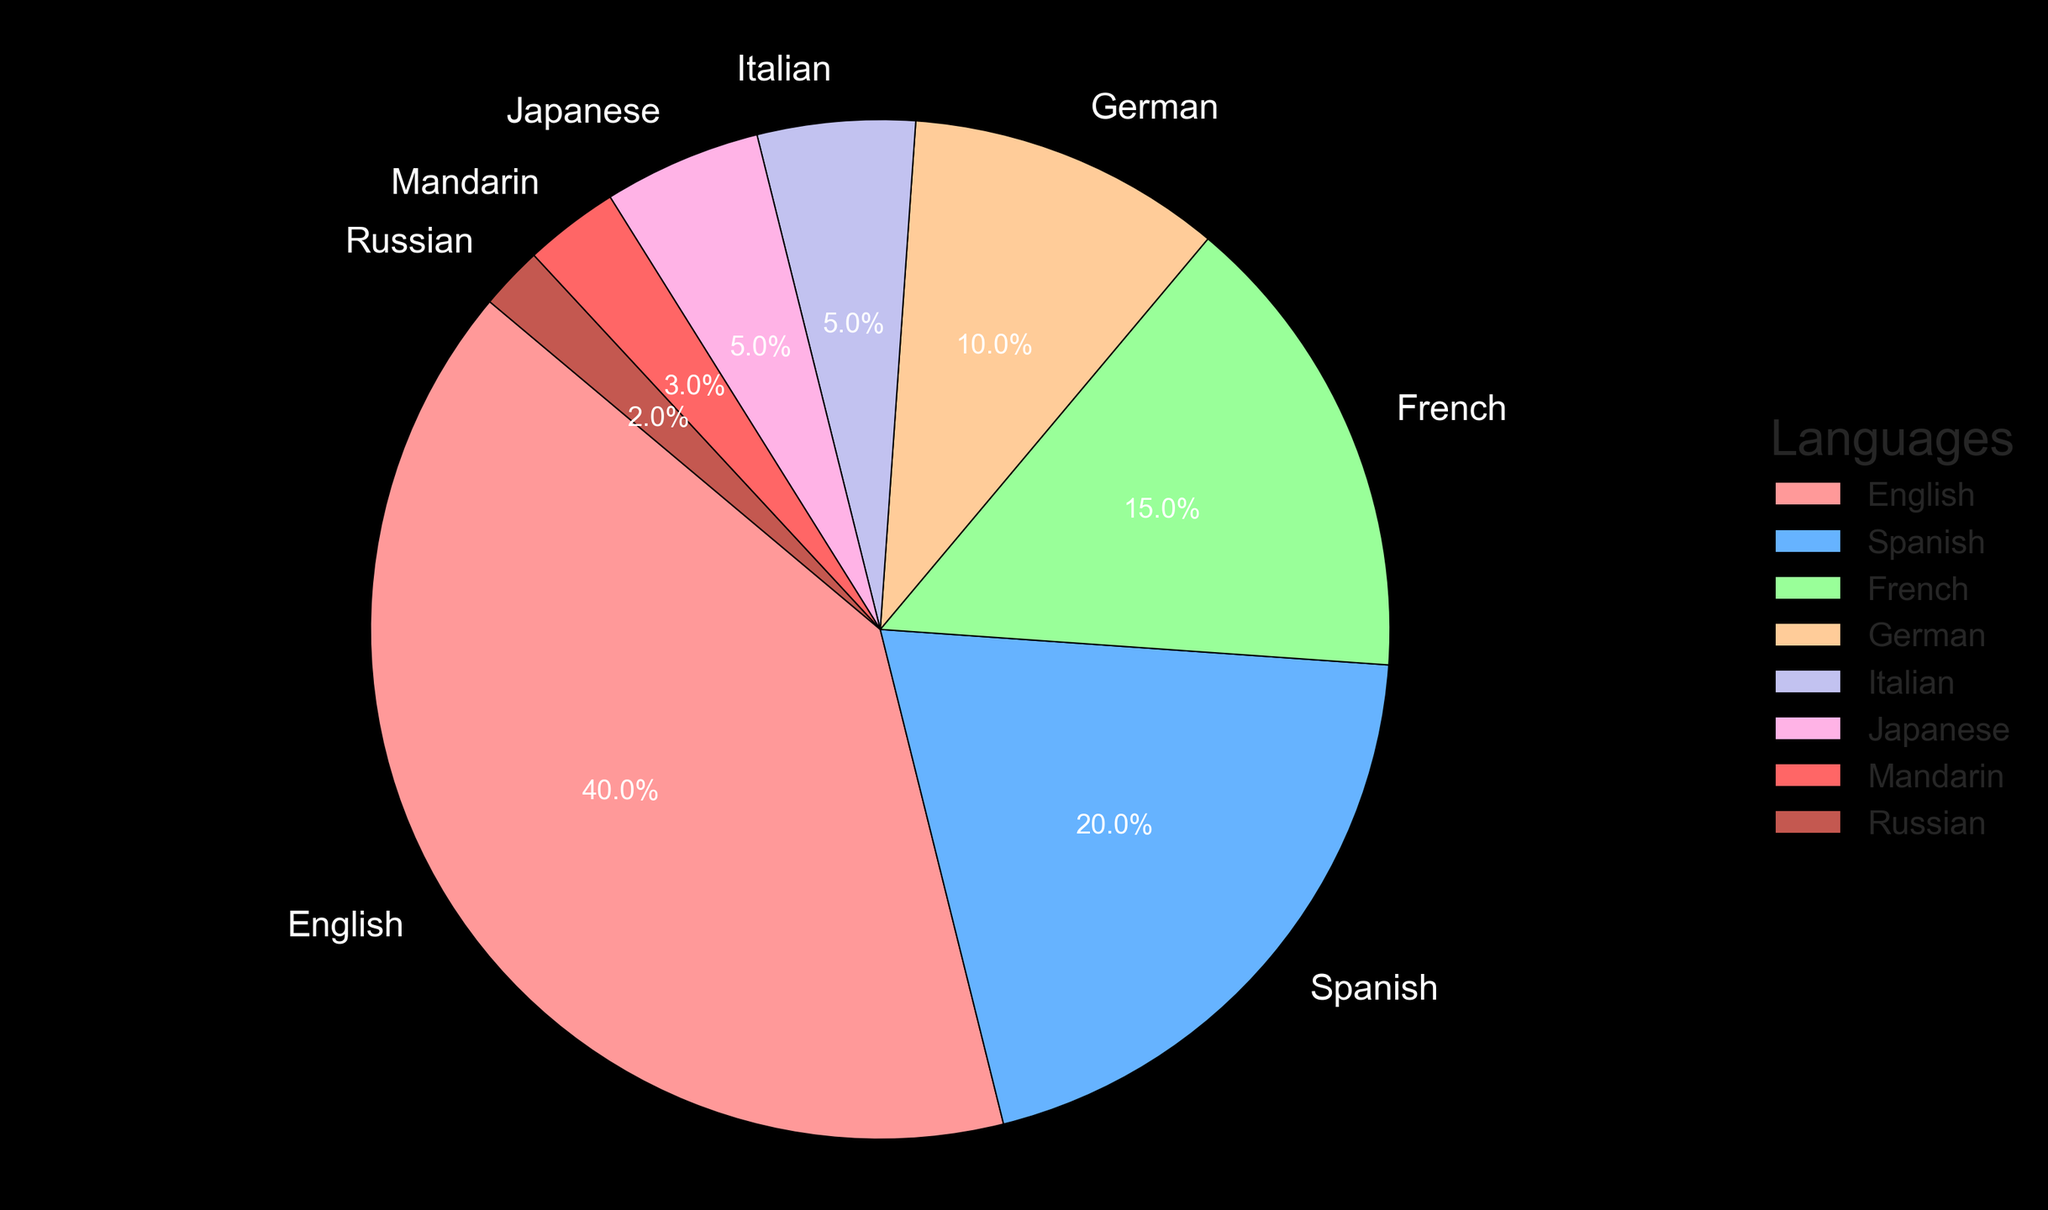What percentage of subtitles are available in Spanish? The pie chart shows the percentage of subtitles for each language, and Spanish makes up 20% of the total.
Answer: 20% What is the combined percentage of subtitles available in French and German? From the pie chart, French subtitles are 15% and German subtitles are 10%. Adding these together gives 15% + 10% = 25%.
Answer: 25% Which language has the third most available subtitles? According to the pie chart, the languages and their percentages in descending order are English (40%), Spanish (20%), and French (15%). Therefore, French has the third most available subtitles.
Answer: French Are there more subtitles available in Japanese or Russian? From the pie chart, Japanese subtitles are 5% of the total, while Russian subtitles are 2%. Therefore, there are more subtitles available in Japanese than in Russian.
Answer: Japanese What percentage of subtitles are available in languages other than English? English subtitles account for 40%, so the remaining percentage is 100% - 40% = 60%.
Answer: 60% Which two languages together make up a smaller percentage than English alone? From the pie chart, English is 40%. The next highest percentages are Spanish (20%) and French (15%), which together are 35%. This is smaller than English alone.
Answer: Spanish and French How many languages have subtitles available for 5% of the movies? The pie chart shows that both Italian and Japanese each account for 5% of the subtitles. Therefore, there are two languages with 5% subtitles each.
Answer: 2 Compare the percentage of English subtitles to the total percentage of subtitles in other European languages (Spanish, French, German, Italian). The pie chart shows English at 40%. Spanish (20%), French (15%), German (10%), and Italian (5%) sum up to 50%. Therefore, subtitles in other European languages collectively hold a higher percentage.
Answer: Other European languages Are there more subtitles available in French or in German plus Italian combined? The pie chart shows French subtitles at 15%, and German plus Italian combined are 10% + 5% = 15%. Both French and the combination of German and Italian have an equal percentage of subtitles.
Answer: Equal Which language has the smallest segment on the pie chart? The smallest segment on the pie chart is for Russian subtitles, which account for 2% of the total.
Answer: Russian 